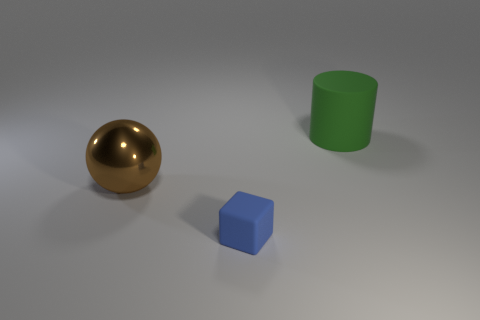Is there anything else that is the same size as the matte cube?
Give a very brief answer. No. How many big green matte cylinders are in front of the large brown metal thing?
Your answer should be compact. 0. Are the object in front of the large brown thing and the object that is on the right side of the blue matte cube made of the same material?
Offer a very short reply. Yes. What shape is the big thing that is in front of the object that is behind the brown object behind the small blue cube?
Ensure brevity in your answer.  Sphere. There is a brown metal object; what shape is it?
Keep it short and to the point. Sphere. What shape is the brown thing that is the same size as the green object?
Keep it short and to the point. Sphere. What number of other things are the same color as the cylinder?
Keep it short and to the point. 0. What number of things are either objects that are left of the large green cylinder or things that are to the left of the tiny thing?
Offer a very short reply. 2. What number of other objects are there of the same material as the tiny cube?
Offer a terse response. 1. Is the large thing right of the small block made of the same material as the tiny blue block?
Ensure brevity in your answer.  Yes. 